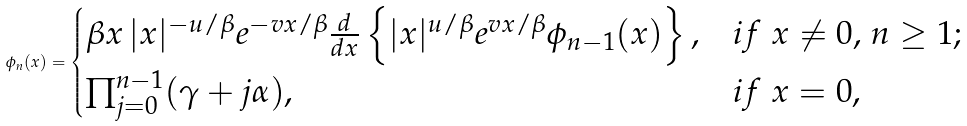<formula> <loc_0><loc_0><loc_500><loc_500>\phi _ { n } ( x ) = \begin{cases} \beta x \, | x | ^ { - u / \beta } e ^ { - v x / \beta } \frac { d } { d x } \left \{ | x | ^ { u / \beta } e ^ { v x / \beta } \phi _ { n - 1 } ( x ) \right \} , & i f \ \text {$x\neq 0$, $n\geq 1$} ; \\ \prod _ { j = 0 } ^ { n - 1 } ( \gamma + j \alpha ) , & i f \ \text {$x=0$} , \end{cases}</formula> 